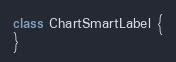Convert code to text. <code><loc_0><loc_0><loc_500><loc_500><_Haxe_>class ChartSmartLabel {
}
</code> 